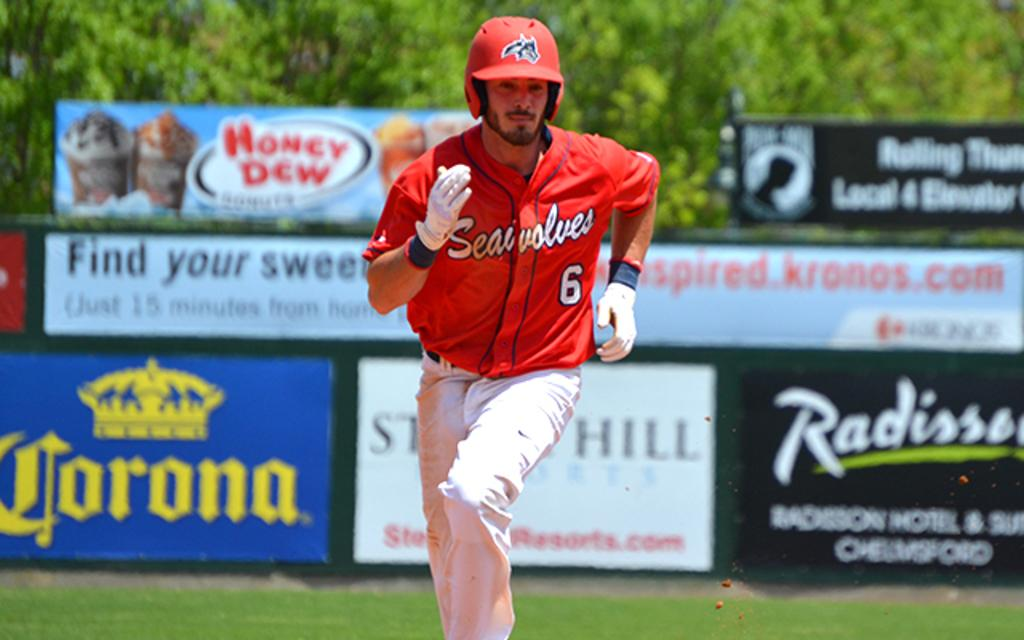<image>
Share a concise interpretation of the image provided. a Seawolves baseball player running to the base with Corona being one of the adverts in the background. 